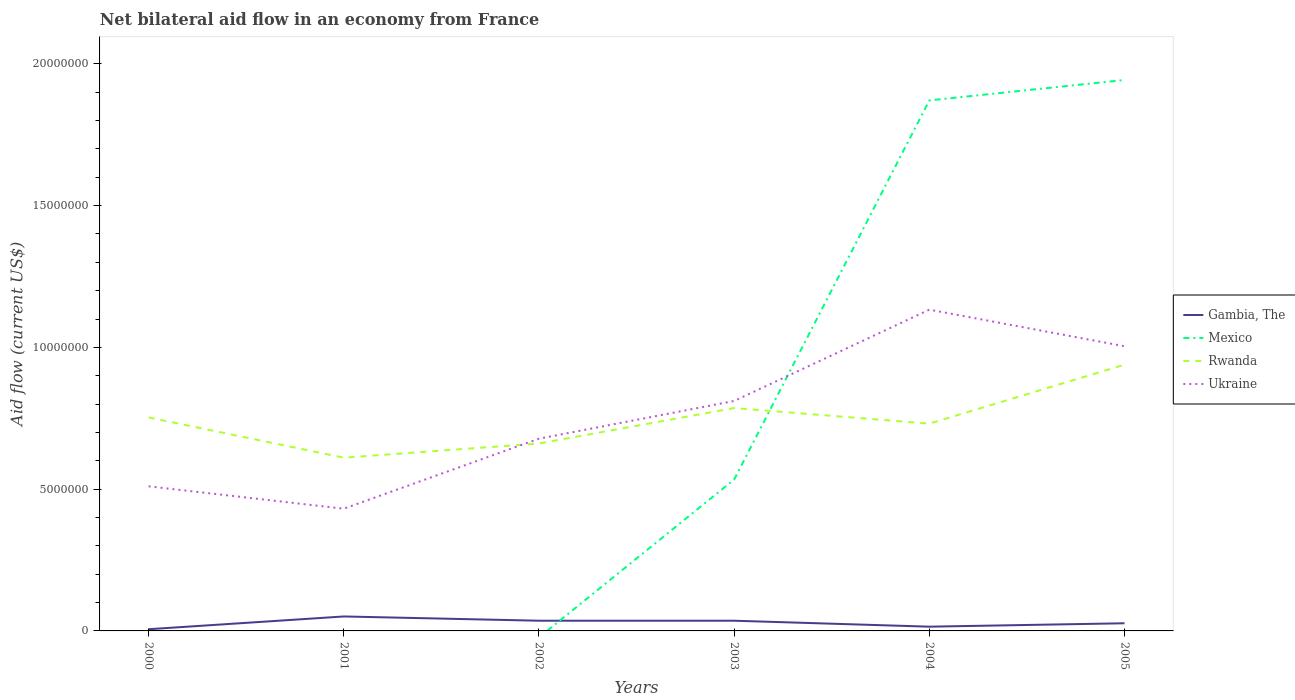Does the line corresponding to Ukraine intersect with the line corresponding to Gambia, The?
Your response must be concise. No. What is the difference between the highest and the second highest net bilateral aid flow in Rwanda?
Give a very brief answer. 3.28e+06. What is the difference between the highest and the lowest net bilateral aid flow in Mexico?
Give a very brief answer. 2. Does the graph contain any zero values?
Offer a terse response. Yes. Does the graph contain grids?
Provide a succinct answer. No. How many legend labels are there?
Keep it short and to the point. 4. What is the title of the graph?
Provide a succinct answer. Net bilateral aid flow in an economy from France. What is the label or title of the Y-axis?
Provide a short and direct response. Aid flow (current US$). What is the Aid flow (current US$) of Rwanda in 2000?
Your answer should be compact. 7.53e+06. What is the Aid flow (current US$) in Ukraine in 2000?
Your answer should be compact. 5.10e+06. What is the Aid flow (current US$) in Gambia, The in 2001?
Your response must be concise. 5.10e+05. What is the Aid flow (current US$) of Mexico in 2001?
Ensure brevity in your answer.  0. What is the Aid flow (current US$) of Rwanda in 2001?
Keep it short and to the point. 6.11e+06. What is the Aid flow (current US$) in Ukraine in 2001?
Give a very brief answer. 4.31e+06. What is the Aid flow (current US$) of Mexico in 2002?
Ensure brevity in your answer.  0. What is the Aid flow (current US$) in Rwanda in 2002?
Give a very brief answer. 6.61e+06. What is the Aid flow (current US$) in Ukraine in 2002?
Your answer should be very brief. 6.78e+06. What is the Aid flow (current US$) in Mexico in 2003?
Keep it short and to the point. 5.34e+06. What is the Aid flow (current US$) of Rwanda in 2003?
Ensure brevity in your answer.  7.86e+06. What is the Aid flow (current US$) of Ukraine in 2003?
Provide a succinct answer. 8.11e+06. What is the Aid flow (current US$) in Gambia, The in 2004?
Your answer should be compact. 1.50e+05. What is the Aid flow (current US$) in Mexico in 2004?
Your answer should be compact. 1.87e+07. What is the Aid flow (current US$) in Rwanda in 2004?
Offer a very short reply. 7.31e+06. What is the Aid flow (current US$) in Ukraine in 2004?
Give a very brief answer. 1.13e+07. What is the Aid flow (current US$) of Mexico in 2005?
Provide a succinct answer. 1.94e+07. What is the Aid flow (current US$) of Rwanda in 2005?
Provide a short and direct response. 9.39e+06. What is the Aid flow (current US$) in Ukraine in 2005?
Offer a terse response. 1.00e+07. Across all years, what is the maximum Aid flow (current US$) in Gambia, The?
Give a very brief answer. 5.10e+05. Across all years, what is the maximum Aid flow (current US$) in Mexico?
Keep it short and to the point. 1.94e+07. Across all years, what is the maximum Aid flow (current US$) in Rwanda?
Provide a short and direct response. 9.39e+06. Across all years, what is the maximum Aid flow (current US$) of Ukraine?
Make the answer very short. 1.13e+07. Across all years, what is the minimum Aid flow (current US$) in Mexico?
Offer a terse response. 0. Across all years, what is the minimum Aid flow (current US$) of Rwanda?
Give a very brief answer. 6.11e+06. Across all years, what is the minimum Aid flow (current US$) of Ukraine?
Offer a terse response. 4.31e+06. What is the total Aid flow (current US$) of Gambia, The in the graph?
Ensure brevity in your answer.  1.71e+06. What is the total Aid flow (current US$) in Mexico in the graph?
Provide a short and direct response. 4.35e+07. What is the total Aid flow (current US$) of Rwanda in the graph?
Provide a short and direct response. 4.48e+07. What is the total Aid flow (current US$) in Ukraine in the graph?
Give a very brief answer. 4.57e+07. What is the difference between the Aid flow (current US$) of Gambia, The in 2000 and that in 2001?
Your response must be concise. -4.50e+05. What is the difference between the Aid flow (current US$) in Rwanda in 2000 and that in 2001?
Give a very brief answer. 1.42e+06. What is the difference between the Aid flow (current US$) in Ukraine in 2000 and that in 2001?
Provide a short and direct response. 7.90e+05. What is the difference between the Aid flow (current US$) in Gambia, The in 2000 and that in 2002?
Keep it short and to the point. -3.00e+05. What is the difference between the Aid flow (current US$) of Rwanda in 2000 and that in 2002?
Your answer should be compact. 9.20e+05. What is the difference between the Aid flow (current US$) in Ukraine in 2000 and that in 2002?
Offer a terse response. -1.68e+06. What is the difference between the Aid flow (current US$) in Gambia, The in 2000 and that in 2003?
Offer a very short reply. -3.00e+05. What is the difference between the Aid flow (current US$) in Rwanda in 2000 and that in 2003?
Your response must be concise. -3.30e+05. What is the difference between the Aid flow (current US$) of Ukraine in 2000 and that in 2003?
Ensure brevity in your answer.  -3.01e+06. What is the difference between the Aid flow (current US$) of Gambia, The in 2000 and that in 2004?
Offer a terse response. -9.00e+04. What is the difference between the Aid flow (current US$) of Rwanda in 2000 and that in 2004?
Provide a succinct answer. 2.20e+05. What is the difference between the Aid flow (current US$) of Ukraine in 2000 and that in 2004?
Ensure brevity in your answer.  -6.23e+06. What is the difference between the Aid flow (current US$) of Gambia, The in 2000 and that in 2005?
Make the answer very short. -2.10e+05. What is the difference between the Aid flow (current US$) of Rwanda in 2000 and that in 2005?
Provide a succinct answer. -1.86e+06. What is the difference between the Aid flow (current US$) of Ukraine in 2000 and that in 2005?
Your answer should be compact. -4.94e+06. What is the difference between the Aid flow (current US$) of Rwanda in 2001 and that in 2002?
Provide a short and direct response. -5.00e+05. What is the difference between the Aid flow (current US$) in Ukraine in 2001 and that in 2002?
Your response must be concise. -2.47e+06. What is the difference between the Aid flow (current US$) of Gambia, The in 2001 and that in 2003?
Ensure brevity in your answer.  1.50e+05. What is the difference between the Aid flow (current US$) of Rwanda in 2001 and that in 2003?
Give a very brief answer. -1.75e+06. What is the difference between the Aid flow (current US$) of Ukraine in 2001 and that in 2003?
Your response must be concise. -3.80e+06. What is the difference between the Aid flow (current US$) of Rwanda in 2001 and that in 2004?
Give a very brief answer. -1.20e+06. What is the difference between the Aid flow (current US$) of Ukraine in 2001 and that in 2004?
Your response must be concise. -7.02e+06. What is the difference between the Aid flow (current US$) of Rwanda in 2001 and that in 2005?
Your response must be concise. -3.28e+06. What is the difference between the Aid flow (current US$) in Ukraine in 2001 and that in 2005?
Ensure brevity in your answer.  -5.73e+06. What is the difference between the Aid flow (current US$) in Rwanda in 2002 and that in 2003?
Provide a succinct answer. -1.25e+06. What is the difference between the Aid flow (current US$) in Ukraine in 2002 and that in 2003?
Offer a terse response. -1.33e+06. What is the difference between the Aid flow (current US$) of Rwanda in 2002 and that in 2004?
Your answer should be compact. -7.00e+05. What is the difference between the Aid flow (current US$) of Ukraine in 2002 and that in 2004?
Your answer should be very brief. -4.55e+06. What is the difference between the Aid flow (current US$) of Rwanda in 2002 and that in 2005?
Your answer should be compact. -2.78e+06. What is the difference between the Aid flow (current US$) of Ukraine in 2002 and that in 2005?
Ensure brevity in your answer.  -3.26e+06. What is the difference between the Aid flow (current US$) of Mexico in 2003 and that in 2004?
Offer a very short reply. -1.34e+07. What is the difference between the Aid flow (current US$) in Rwanda in 2003 and that in 2004?
Ensure brevity in your answer.  5.50e+05. What is the difference between the Aid flow (current US$) in Ukraine in 2003 and that in 2004?
Provide a succinct answer. -3.22e+06. What is the difference between the Aid flow (current US$) of Gambia, The in 2003 and that in 2005?
Offer a very short reply. 9.00e+04. What is the difference between the Aid flow (current US$) of Mexico in 2003 and that in 2005?
Your response must be concise. -1.41e+07. What is the difference between the Aid flow (current US$) of Rwanda in 2003 and that in 2005?
Keep it short and to the point. -1.53e+06. What is the difference between the Aid flow (current US$) in Ukraine in 2003 and that in 2005?
Make the answer very short. -1.93e+06. What is the difference between the Aid flow (current US$) of Mexico in 2004 and that in 2005?
Keep it short and to the point. -7.20e+05. What is the difference between the Aid flow (current US$) of Rwanda in 2004 and that in 2005?
Provide a succinct answer. -2.08e+06. What is the difference between the Aid flow (current US$) in Ukraine in 2004 and that in 2005?
Your answer should be very brief. 1.29e+06. What is the difference between the Aid flow (current US$) of Gambia, The in 2000 and the Aid flow (current US$) of Rwanda in 2001?
Offer a terse response. -6.05e+06. What is the difference between the Aid flow (current US$) in Gambia, The in 2000 and the Aid flow (current US$) in Ukraine in 2001?
Offer a terse response. -4.25e+06. What is the difference between the Aid flow (current US$) in Rwanda in 2000 and the Aid flow (current US$) in Ukraine in 2001?
Your answer should be very brief. 3.22e+06. What is the difference between the Aid flow (current US$) of Gambia, The in 2000 and the Aid flow (current US$) of Rwanda in 2002?
Your answer should be compact. -6.55e+06. What is the difference between the Aid flow (current US$) of Gambia, The in 2000 and the Aid flow (current US$) of Ukraine in 2002?
Your answer should be very brief. -6.72e+06. What is the difference between the Aid flow (current US$) in Rwanda in 2000 and the Aid flow (current US$) in Ukraine in 2002?
Give a very brief answer. 7.50e+05. What is the difference between the Aid flow (current US$) in Gambia, The in 2000 and the Aid flow (current US$) in Mexico in 2003?
Offer a terse response. -5.28e+06. What is the difference between the Aid flow (current US$) in Gambia, The in 2000 and the Aid flow (current US$) in Rwanda in 2003?
Your answer should be compact. -7.80e+06. What is the difference between the Aid flow (current US$) of Gambia, The in 2000 and the Aid flow (current US$) of Ukraine in 2003?
Your answer should be compact. -8.05e+06. What is the difference between the Aid flow (current US$) of Rwanda in 2000 and the Aid flow (current US$) of Ukraine in 2003?
Your response must be concise. -5.80e+05. What is the difference between the Aid flow (current US$) of Gambia, The in 2000 and the Aid flow (current US$) of Mexico in 2004?
Keep it short and to the point. -1.86e+07. What is the difference between the Aid flow (current US$) in Gambia, The in 2000 and the Aid flow (current US$) in Rwanda in 2004?
Provide a short and direct response. -7.25e+06. What is the difference between the Aid flow (current US$) of Gambia, The in 2000 and the Aid flow (current US$) of Ukraine in 2004?
Provide a short and direct response. -1.13e+07. What is the difference between the Aid flow (current US$) of Rwanda in 2000 and the Aid flow (current US$) of Ukraine in 2004?
Your response must be concise. -3.80e+06. What is the difference between the Aid flow (current US$) of Gambia, The in 2000 and the Aid flow (current US$) of Mexico in 2005?
Offer a very short reply. -1.94e+07. What is the difference between the Aid flow (current US$) in Gambia, The in 2000 and the Aid flow (current US$) in Rwanda in 2005?
Your answer should be compact. -9.33e+06. What is the difference between the Aid flow (current US$) of Gambia, The in 2000 and the Aid flow (current US$) of Ukraine in 2005?
Your answer should be compact. -9.98e+06. What is the difference between the Aid flow (current US$) of Rwanda in 2000 and the Aid flow (current US$) of Ukraine in 2005?
Your answer should be very brief. -2.51e+06. What is the difference between the Aid flow (current US$) of Gambia, The in 2001 and the Aid flow (current US$) of Rwanda in 2002?
Your answer should be very brief. -6.10e+06. What is the difference between the Aid flow (current US$) of Gambia, The in 2001 and the Aid flow (current US$) of Ukraine in 2002?
Your answer should be compact. -6.27e+06. What is the difference between the Aid flow (current US$) in Rwanda in 2001 and the Aid flow (current US$) in Ukraine in 2002?
Your answer should be compact. -6.70e+05. What is the difference between the Aid flow (current US$) of Gambia, The in 2001 and the Aid flow (current US$) of Mexico in 2003?
Your answer should be compact. -4.83e+06. What is the difference between the Aid flow (current US$) of Gambia, The in 2001 and the Aid flow (current US$) of Rwanda in 2003?
Ensure brevity in your answer.  -7.35e+06. What is the difference between the Aid flow (current US$) in Gambia, The in 2001 and the Aid flow (current US$) in Ukraine in 2003?
Your response must be concise. -7.60e+06. What is the difference between the Aid flow (current US$) in Rwanda in 2001 and the Aid flow (current US$) in Ukraine in 2003?
Your answer should be very brief. -2.00e+06. What is the difference between the Aid flow (current US$) of Gambia, The in 2001 and the Aid flow (current US$) of Mexico in 2004?
Give a very brief answer. -1.82e+07. What is the difference between the Aid flow (current US$) in Gambia, The in 2001 and the Aid flow (current US$) in Rwanda in 2004?
Give a very brief answer. -6.80e+06. What is the difference between the Aid flow (current US$) in Gambia, The in 2001 and the Aid flow (current US$) in Ukraine in 2004?
Your answer should be compact. -1.08e+07. What is the difference between the Aid flow (current US$) in Rwanda in 2001 and the Aid flow (current US$) in Ukraine in 2004?
Provide a succinct answer. -5.22e+06. What is the difference between the Aid flow (current US$) of Gambia, The in 2001 and the Aid flow (current US$) of Mexico in 2005?
Your response must be concise. -1.89e+07. What is the difference between the Aid flow (current US$) of Gambia, The in 2001 and the Aid flow (current US$) of Rwanda in 2005?
Provide a succinct answer. -8.88e+06. What is the difference between the Aid flow (current US$) in Gambia, The in 2001 and the Aid flow (current US$) in Ukraine in 2005?
Offer a very short reply. -9.53e+06. What is the difference between the Aid flow (current US$) in Rwanda in 2001 and the Aid flow (current US$) in Ukraine in 2005?
Offer a terse response. -3.93e+06. What is the difference between the Aid flow (current US$) of Gambia, The in 2002 and the Aid flow (current US$) of Mexico in 2003?
Give a very brief answer. -4.98e+06. What is the difference between the Aid flow (current US$) of Gambia, The in 2002 and the Aid flow (current US$) of Rwanda in 2003?
Give a very brief answer. -7.50e+06. What is the difference between the Aid flow (current US$) in Gambia, The in 2002 and the Aid flow (current US$) in Ukraine in 2003?
Your answer should be compact. -7.75e+06. What is the difference between the Aid flow (current US$) in Rwanda in 2002 and the Aid flow (current US$) in Ukraine in 2003?
Provide a short and direct response. -1.50e+06. What is the difference between the Aid flow (current US$) in Gambia, The in 2002 and the Aid flow (current US$) in Mexico in 2004?
Your response must be concise. -1.84e+07. What is the difference between the Aid flow (current US$) of Gambia, The in 2002 and the Aid flow (current US$) of Rwanda in 2004?
Your answer should be compact. -6.95e+06. What is the difference between the Aid flow (current US$) of Gambia, The in 2002 and the Aid flow (current US$) of Ukraine in 2004?
Your answer should be very brief. -1.10e+07. What is the difference between the Aid flow (current US$) in Rwanda in 2002 and the Aid flow (current US$) in Ukraine in 2004?
Keep it short and to the point. -4.72e+06. What is the difference between the Aid flow (current US$) in Gambia, The in 2002 and the Aid flow (current US$) in Mexico in 2005?
Provide a short and direct response. -1.91e+07. What is the difference between the Aid flow (current US$) of Gambia, The in 2002 and the Aid flow (current US$) of Rwanda in 2005?
Make the answer very short. -9.03e+06. What is the difference between the Aid flow (current US$) of Gambia, The in 2002 and the Aid flow (current US$) of Ukraine in 2005?
Ensure brevity in your answer.  -9.68e+06. What is the difference between the Aid flow (current US$) of Rwanda in 2002 and the Aid flow (current US$) of Ukraine in 2005?
Ensure brevity in your answer.  -3.43e+06. What is the difference between the Aid flow (current US$) of Gambia, The in 2003 and the Aid flow (current US$) of Mexico in 2004?
Offer a terse response. -1.84e+07. What is the difference between the Aid flow (current US$) in Gambia, The in 2003 and the Aid flow (current US$) in Rwanda in 2004?
Provide a succinct answer. -6.95e+06. What is the difference between the Aid flow (current US$) of Gambia, The in 2003 and the Aid flow (current US$) of Ukraine in 2004?
Your answer should be very brief. -1.10e+07. What is the difference between the Aid flow (current US$) in Mexico in 2003 and the Aid flow (current US$) in Rwanda in 2004?
Make the answer very short. -1.97e+06. What is the difference between the Aid flow (current US$) in Mexico in 2003 and the Aid flow (current US$) in Ukraine in 2004?
Offer a terse response. -5.99e+06. What is the difference between the Aid flow (current US$) in Rwanda in 2003 and the Aid flow (current US$) in Ukraine in 2004?
Provide a short and direct response. -3.47e+06. What is the difference between the Aid flow (current US$) in Gambia, The in 2003 and the Aid flow (current US$) in Mexico in 2005?
Keep it short and to the point. -1.91e+07. What is the difference between the Aid flow (current US$) of Gambia, The in 2003 and the Aid flow (current US$) of Rwanda in 2005?
Your response must be concise. -9.03e+06. What is the difference between the Aid flow (current US$) of Gambia, The in 2003 and the Aid flow (current US$) of Ukraine in 2005?
Give a very brief answer. -9.68e+06. What is the difference between the Aid flow (current US$) of Mexico in 2003 and the Aid flow (current US$) of Rwanda in 2005?
Give a very brief answer. -4.05e+06. What is the difference between the Aid flow (current US$) of Mexico in 2003 and the Aid flow (current US$) of Ukraine in 2005?
Keep it short and to the point. -4.70e+06. What is the difference between the Aid flow (current US$) in Rwanda in 2003 and the Aid flow (current US$) in Ukraine in 2005?
Your answer should be compact. -2.18e+06. What is the difference between the Aid flow (current US$) of Gambia, The in 2004 and the Aid flow (current US$) of Mexico in 2005?
Offer a terse response. -1.93e+07. What is the difference between the Aid flow (current US$) of Gambia, The in 2004 and the Aid flow (current US$) of Rwanda in 2005?
Your answer should be compact. -9.24e+06. What is the difference between the Aid flow (current US$) of Gambia, The in 2004 and the Aid flow (current US$) of Ukraine in 2005?
Offer a very short reply. -9.89e+06. What is the difference between the Aid flow (current US$) of Mexico in 2004 and the Aid flow (current US$) of Rwanda in 2005?
Offer a very short reply. 9.32e+06. What is the difference between the Aid flow (current US$) in Mexico in 2004 and the Aid flow (current US$) in Ukraine in 2005?
Give a very brief answer. 8.67e+06. What is the difference between the Aid flow (current US$) of Rwanda in 2004 and the Aid flow (current US$) of Ukraine in 2005?
Provide a short and direct response. -2.73e+06. What is the average Aid flow (current US$) in Gambia, The per year?
Give a very brief answer. 2.85e+05. What is the average Aid flow (current US$) of Mexico per year?
Provide a succinct answer. 7.25e+06. What is the average Aid flow (current US$) of Rwanda per year?
Make the answer very short. 7.47e+06. What is the average Aid flow (current US$) in Ukraine per year?
Your answer should be compact. 7.61e+06. In the year 2000, what is the difference between the Aid flow (current US$) in Gambia, The and Aid flow (current US$) in Rwanda?
Make the answer very short. -7.47e+06. In the year 2000, what is the difference between the Aid flow (current US$) in Gambia, The and Aid flow (current US$) in Ukraine?
Keep it short and to the point. -5.04e+06. In the year 2000, what is the difference between the Aid flow (current US$) of Rwanda and Aid flow (current US$) of Ukraine?
Give a very brief answer. 2.43e+06. In the year 2001, what is the difference between the Aid flow (current US$) in Gambia, The and Aid flow (current US$) in Rwanda?
Keep it short and to the point. -5.60e+06. In the year 2001, what is the difference between the Aid flow (current US$) of Gambia, The and Aid flow (current US$) of Ukraine?
Give a very brief answer. -3.80e+06. In the year 2001, what is the difference between the Aid flow (current US$) of Rwanda and Aid flow (current US$) of Ukraine?
Keep it short and to the point. 1.80e+06. In the year 2002, what is the difference between the Aid flow (current US$) in Gambia, The and Aid flow (current US$) in Rwanda?
Ensure brevity in your answer.  -6.25e+06. In the year 2002, what is the difference between the Aid flow (current US$) of Gambia, The and Aid flow (current US$) of Ukraine?
Offer a very short reply. -6.42e+06. In the year 2002, what is the difference between the Aid flow (current US$) in Rwanda and Aid flow (current US$) in Ukraine?
Ensure brevity in your answer.  -1.70e+05. In the year 2003, what is the difference between the Aid flow (current US$) of Gambia, The and Aid flow (current US$) of Mexico?
Your answer should be compact. -4.98e+06. In the year 2003, what is the difference between the Aid flow (current US$) of Gambia, The and Aid flow (current US$) of Rwanda?
Offer a very short reply. -7.50e+06. In the year 2003, what is the difference between the Aid flow (current US$) in Gambia, The and Aid flow (current US$) in Ukraine?
Provide a succinct answer. -7.75e+06. In the year 2003, what is the difference between the Aid flow (current US$) in Mexico and Aid flow (current US$) in Rwanda?
Offer a terse response. -2.52e+06. In the year 2003, what is the difference between the Aid flow (current US$) in Mexico and Aid flow (current US$) in Ukraine?
Provide a succinct answer. -2.77e+06. In the year 2004, what is the difference between the Aid flow (current US$) in Gambia, The and Aid flow (current US$) in Mexico?
Offer a terse response. -1.86e+07. In the year 2004, what is the difference between the Aid flow (current US$) of Gambia, The and Aid flow (current US$) of Rwanda?
Your answer should be very brief. -7.16e+06. In the year 2004, what is the difference between the Aid flow (current US$) of Gambia, The and Aid flow (current US$) of Ukraine?
Give a very brief answer. -1.12e+07. In the year 2004, what is the difference between the Aid flow (current US$) of Mexico and Aid flow (current US$) of Rwanda?
Give a very brief answer. 1.14e+07. In the year 2004, what is the difference between the Aid flow (current US$) in Mexico and Aid flow (current US$) in Ukraine?
Your response must be concise. 7.38e+06. In the year 2004, what is the difference between the Aid flow (current US$) of Rwanda and Aid flow (current US$) of Ukraine?
Provide a succinct answer. -4.02e+06. In the year 2005, what is the difference between the Aid flow (current US$) in Gambia, The and Aid flow (current US$) in Mexico?
Keep it short and to the point. -1.92e+07. In the year 2005, what is the difference between the Aid flow (current US$) in Gambia, The and Aid flow (current US$) in Rwanda?
Your response must be concise. -9.12e+06. In the year 2005, what is the difference between the Aid flow (current US$) in Gambia, The and Aid flow (current US$) in Ukraine?
Keep it short and to the point. -9.77e+06. In the year 2005, what is the difference between the Aid flow (current US$) in Mexico and Aid flow (current US$) in Rwanda?
Your answer should be compact. 1.00e+07. In the year 2005, what is the difference between the Aid flow (current US$) of Mexico and Aid flow (current US$) of Ukraine?
Offer a very short reply. 9.39e+06. In the year 2005, what is the difference between the Aid flow (current US$) in Rwanda and Aid flow (current US$) in Ukraine?
Offer a terse response. -6.50e+05. What is the ratio of the Aid flow (current US$) of Gambia, The in 2000 to that in 2001?
Make the answer very short. 0.12. What is the ratio of the Aid flow (current US$) of Rwanda in 2000 to that in 2001?
Your response must be concise. 1.23. What is the ratio of the Aid flow (current US$) of Ukraine in 2000 to that in 2001?
Your answer should be compact. 1.18. What is the ratio of the Aid flow (current US$) in Gambia, The in 2000 to that in 2002?
Provide a short and direct response. 0.17. What is the ratio of the Aid flow (current US$) in Rwanda in 2000 to that in 2002?
Your answer should be compact. 1.14. What is the ratio of the Aid flow (current US$) of Ukraine in 2000 to that in 2002?
Your answer should be compact. 0.75. What is the ratio of the Aid flow (current US$) in Rwanda in 2000 to that in 2003?
Your answer should be very brief. 0.96. What is the ratio of the Aid flow (current US$) in Ukraine in 2000 to that in 2003?
Ensure brevity in your answer.  0.63. What is the ratio of the Aid flow (current US$) of Rwanda in 2000 to that in 2004?
Your answer should be compact. 1.03. What is the ratio of the Aid flow (current US$) of Ukraine in 2000 to that in 2004?
Provide a succinct answer. 0.45. What is the ratio of the Aid flow (current US$) of Gambia, The in 2000 to that in 2005?
Provide a short and direct response. 0.22. What is the ratio of the Aid flow (current US$) in Rwanda in 2000 to that in 2005?
Offer a very short reply. 0.8. What is the ratio of the Aid flow (current US$) of Ukraine in 2000 to that in 2005?
Provide a short and direct response. 0.51. What is the ratio of the Aid flow (current US$) of Gambia, The in 2001 to that in 2002?
Offer a terse response. 1.42. What is the ratio of the Aid flow (current US$) in Rwanda in 2001 to that in 2002?
Keep it short and to the point. 0.92. What is the ratio of the Aid flow (current US$) in Ukraine in 2001 to that in 2002?
Your answer should be compact. 0.64. What is the ratio of the Aid flow (current US$) in Gambia, The in 2001 to that in 2003?
Your answer should be compact. 1.42. What is the ratio of the Aid flow (current US$) of Rwanda in 2001 to that in 2003?
Your answer should be compact. 0.78. What is the ratio of the Aid flow (current US$) of Ukraine in 2001 to that in 2003?
Make the answer very short. 0.53. What is the ratio of the Aid flow (current US$) of Gambia, The in 2001 to that in 2004?
Your answer should be very brief. 3.4. What is the ratio of the Aid flow (current US$) in Rwanda in 2001 to that in 2004?
Your answer should be compact. 0.84. What is the ratio of the Aid flow (current US$) in Ukraine in 2001 to that in 2004?
Provide a short and direct response. 0.38. What is the ratio of the Aid flow (current US$) in Gambia, The in 2001 to that in 2005?
Give a very brief answer. 1.89. What is the ratio of the Aid flow (current US$) of Rwanda in 2001 to that in 2005?
Give a very brief answer. 0.65. What is the ratio of the Aid flow (current US$) in Ukraine in 2001 to that in 2005?
Your answer should be compact. 0.43. What is the ratio of the Aid flow (current US$) in Gambia, The in 2002 to that in 2003?
Give a very brief answer. 1. What is the ratio of the Aid flow (current US$) in Rwanda in 2002 to that in 2003?
Ensure brevity in your answer.  0.84. What is the ratio of the Aid flow (current US$) of Ukraine in 2002 to that in 2003?
Provide a succinct answer. 0.84. What is the ratio of the Aid flow (current US$) in Gambia, The in 2002 to that in 2004?
Make the answer very short. 2.4. What is the ratio of the Aid flow (current US$) in Rwanda in 2002 to that in 2004?
Ensure brevity in your answer.  0.9. What is the ratio of the Aid flow (current US$) of Ukraine in 2002 to that in 2004?
Give a very brief answer. 0.6. What is the ratio of the Aid flow (current US$) of Rwanda in 2002 to that in 2005?
Your response must be concise. 0.7. What is the ratio of the Aid flow (current US$) in Ukraine in 2002 to that in 2005?
Your answer should be compact. 0.68. What is the ratio of the Aid flow (current US$) in Gambia, The in 2003 to that in 2004?
Your response must be concise. 2.4. What is the ratio of the Aid flow (current US$) of Mexico in 2003 to that in 2004?
Offer a terse response. 0.29. What is the ratio of the Aid flow (current US$) in Rwanda in 2003 to that in 2004?
Your response must be concise. 1.08. What is the ratio of the Aid flow (current US$) in Ukraine in 2003 to that in 2004?
Offer a terse response. 0.72. What is the ratio of the Aid flow (current US$) of Mexico in 2003 to that in 2005?
Keep it short and to the point. 0.27. What is the ratio of the Aid flow (current US$) of Rwanda in 2003 to that in 2005?
Provide a short and direct response. 0.84. What is the ratio of the Aid flow (current US$) of Ukraine in 2003 to that in 2005?
Give a very brief answer. 0.81. What is the ratio of the Aid flow (current US$) in Gambia, The in 2004 to that in 2005?
Your response must be concise. 0.56. What is the ratio of the Aid flow (current US$) of Mexico in 2004 to that in 2005?
Keep it short and to the point. 0.96. What is the ratio of the Aid flow (current US$) in Rwanda in 2004 to that in 2005?
Your answer should be compact. 0.78. What is the ratio of the Aid flow (current US$) in Ukraine in 2004 to that in 2005?
Your answer should be very brief. 1.13. What is the difference between the highest and the second highest Aid flow (current US$) of Gambia, The?
Give a very brief answer. 1.50e+05. What is the difference between the highest and the second highest Aid flow (current US$) of Mexico?
Ensure brevity in your answer.  7.20e+05. What is the difference between the highest and the second highest Aid flow (current US$) in Rwanda?
Give a very brief answer. 1.53e+06. What is the difference between the highest and the second highest Aid flow (current US$) in Ukraine?
Make the answer very short. 1.29e+06. What is the difference between the highest and the lowest Aid flow (current US$) in Mexico?
Your answer should be very brief. 1.94e+07. What is the difference between the highest and the lowest Aid flow (current US$) of Rwanda?
Offer a very short reply. 3.28e+06. What is the difference between the highest and the lowest Aid flow (current US$) of Ukraine?
Your answer should be compact. 7.02e+06. 